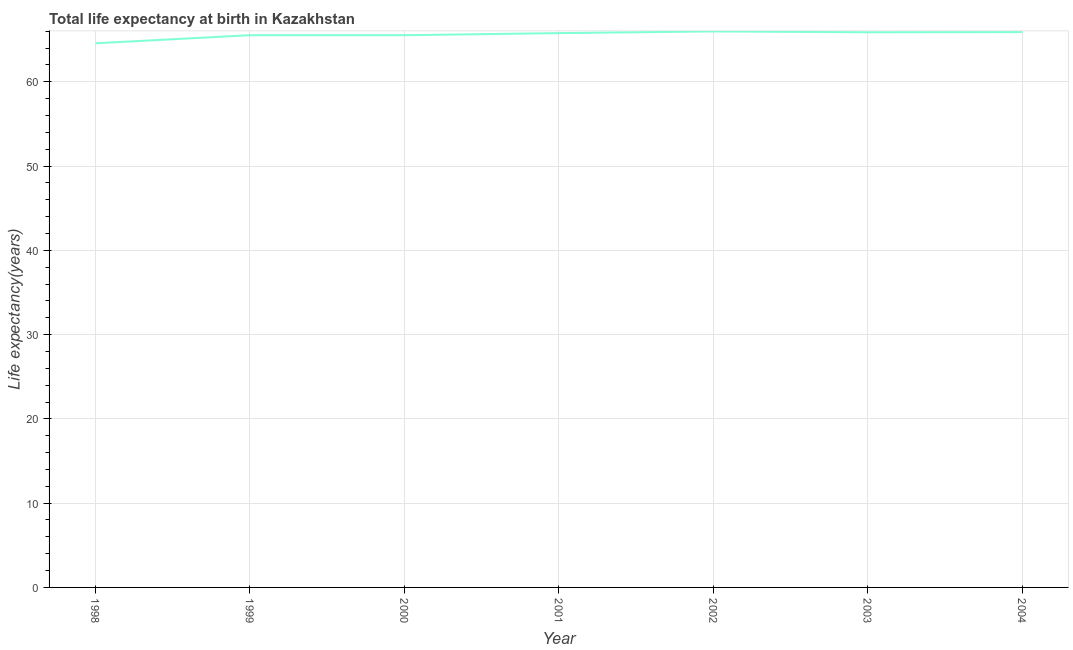What is the life expectancy at birth in 2004?
Provide a succinct answer. 65.89. Across all years, what is the maximum life expectancy at birth?
Your answer should be compact. 65.97. Across all years, what is the minimum life expectancy at birth?
Your answer should be very brief. 64.56. What is the sum of the life expectancy at birth?
Make the answer very short. 459.09. What is the difference between the life expectancy at birth in 2001 and 2002?
Offer a very short reply. -0.2. What is the average life expectancy at birth per year?
Provide a succinct answer. 65.58. What is the median life expectancy at birth?
Your response must be concise. 65.77. What is the ratio of the life expectancy at birth in 1999 to that in 2003?
Provide a succinct answer. 0.99. Is the life expectancy at birth in 2000 less than that in 2003?
Provide a short and direct response. Yes. What is the difference between the highest and the second highest life expectancy at birth?
Make the answer very short. 0.08. Is the sum of the life expectancy at birth in 2001 and 2003 greater than the maximum life expectancy at birth across all years?
Ensure brevity in your answer.  Yes. What is the difference between the highest and the lowest life expectancy at birth?
Your answer should be very brief. 1.41. How many years are there in the graph?
Ensure brevity in your answer.  7. Are the values on the major ticks of Y-axis written in scientific E-notation?
Keep it short and to the point. No. Does the graph contain grids?
Offer a very short reply. Yes. What is the title of the graph?
Your answer should be very brief. Total life expectancy at birth in Kazakhstan. What is the label or title of the X-axis?
Provide a succinct answer. Year. What is the label or title of the Y-axis?
Offer a very short reply. Life expectancy(years). What is the Life expectancy(years) of 1998?
Give a very brief answer. 64.56. What is the Life expectancy(years) in 1999?
Give a very brief answer. 65.52. What is the Life expectancy(years) in 2000?
Offer a terse response. 65.52. What is the Life expectancy(years) in 2001?
Keep it short and to the point. 65.77. What is the Life expectancy(years) in 2002?
Make the answer very short. 65.97. What is the Life expectancy(years) of 2003?
Your response must be concise. 65.87. What is the Life expectancy(years) of 2004?
Give a very brief answer. 65.89. What is the difference between the Life expectancy(years) in 1998 and 1999?
Ensure brevity in your answer.  -0.96. What is the difference between the Life expectancy(years) in 1998 and 2000?
Offer a terse response. -0.96. What is the difference between the Life expectancy(years) in 1998 and 2001?
Your answer should be very brief. -1.21. What is the difference between the Life expectancy(years) in 1998 and 2002?
Provide a succinct answer. -1.41. What is the difference between the Life expectancy(years) in 1998 and 2003?
Offer a very short reply. -1.3. What is the difference between the Life expectancy(years) in 1998 and 2004?
Make the answer very short. -1.33. What is the difference between the Life expectancy(years) in 1999 and 2000?
Give a very brief answer. 0. What is the difference between the Life expectancy(years) in 1999 and 2001?
Your answer should be compact. -0.25. What is the difference between the Life expectancy(years) in 1999 and 2002?
Your answer should be compact. -0.45. What is the difference between the Life expectancy(years) in 1999 and 2003?
Keep it short and to the point. -0.35. What is the difference between the Life expectancy(years) in 1999 and 2004?
Keep it short and to the point. -0.37. What is the difference between the Life expectancy(years) in 2000 and 2001?
Your answer should be compact. -0.25. What is the difference between the Life expectancy(years) in 2000 and 2002?
Provide a short and direct response. -0.45. What is the difference between the Life expectancy(years) in 2000 and 2003?
Provide a succinct answer. -0.35. What is the difference between the Life expectancy(years) in 2000 and 2004?
Provide a succinct answer. -0.37. What is the difference between the Life expectancy(years) in 2001 and 2003?
Offer a very short reply. -0.1. What is the difference between the Life expectancy(years) in 2001 and 2004?
Your answer should be compact. -0.12. What is the difference between the Life expectancy(years) in 2002 and 2003?
Your answer should be very brief. 0.1. What is the difference between the Life expectancy(years) in 2002 and 2004?
Provide a short and direct response. 0.08. What is the difference between the Life expectancy(years) in 2003 and 2004?
Give a very brief answer. -0.02. What is the ratio of the Life expectancy(years) in 1999 to that in 2001?
Offer a very short reply. 1. What is the ratio of the Life expectancy(years) in 2000 to that in 2001?
Your answer should be compact. 1. What is the ratio of the Life expectancy(years) in 2000 to that in 2002?
Your answer should be very brief. 0.99. What is the ratio of the Life expectancy(years) in 2000 to that in 2003?
Give a very brief answer. 0.99. What is the ratio of the Life expectancy(years) in 2001 to that in 2002?
Ensure brevity in your answer.  1. What is the ratio of the Life expectancy(years) in 2002 to that in 2003?
Keep it short and to the point. 1. What is the ratio of the Life expectancy(years) in 2002 to that in 2004?
Your response must be concise. 1. What is the ratio of the Life expectancy(years) in 2003 to that in 2004?
Your answer should be compact. 1. 